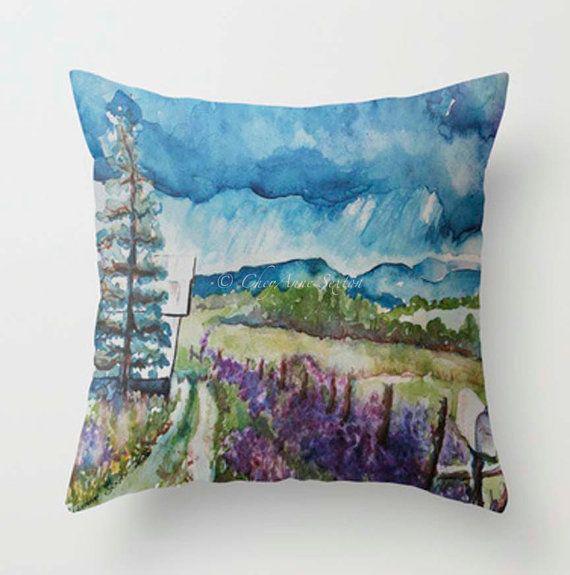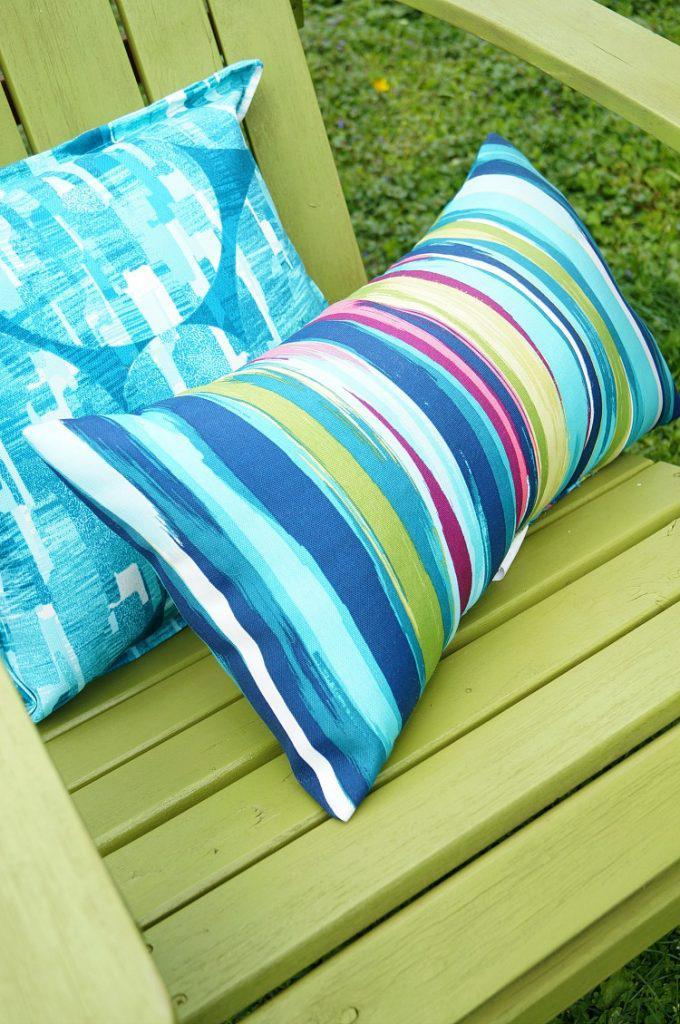The first image is the image on the left, the second image is the image on the right. Considering the images on both sides, is "There is at least two pillows in the right image." valid? Answer yes or no. Yes. The first image is the image on the left, the second image is the image on the right. Considering the images on both sides, is "There are flowers on at least one pillow in each image, and none of the pillow are fuzzy." valid? Answer yes or no. No. 